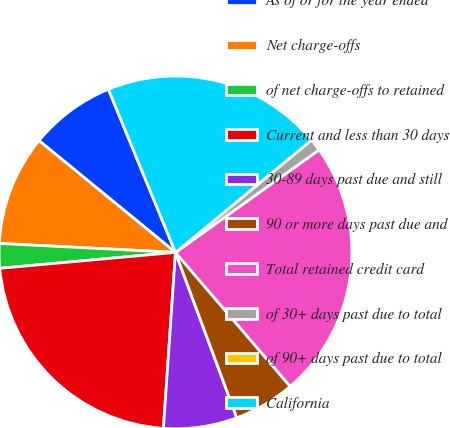Convert chart. <chart><loc_0><loc_0><loc_500><loc_500><pie_chart><fcel>As of or for the year ended<fcel>Net charge-offs<fcel>of net charge-offs to retained<fcel>Current and less than 30 days<fcel>30-89 days past due and still<fcel>90 or more days past due and<fcel>Total retained credit card<fcel>of 30+ days past due to total<fcel>of 90+ days past due to total<fcel>California<nl><fcel>7.87%<fcel>10.11%<fcel>2.25%<fcel>22.47%<fcel>6.74%<fcel>5.62%<fcel>23.6%<fcel>1.12%<fcel>0.0%<fcel>20.22%<nl></chart> 